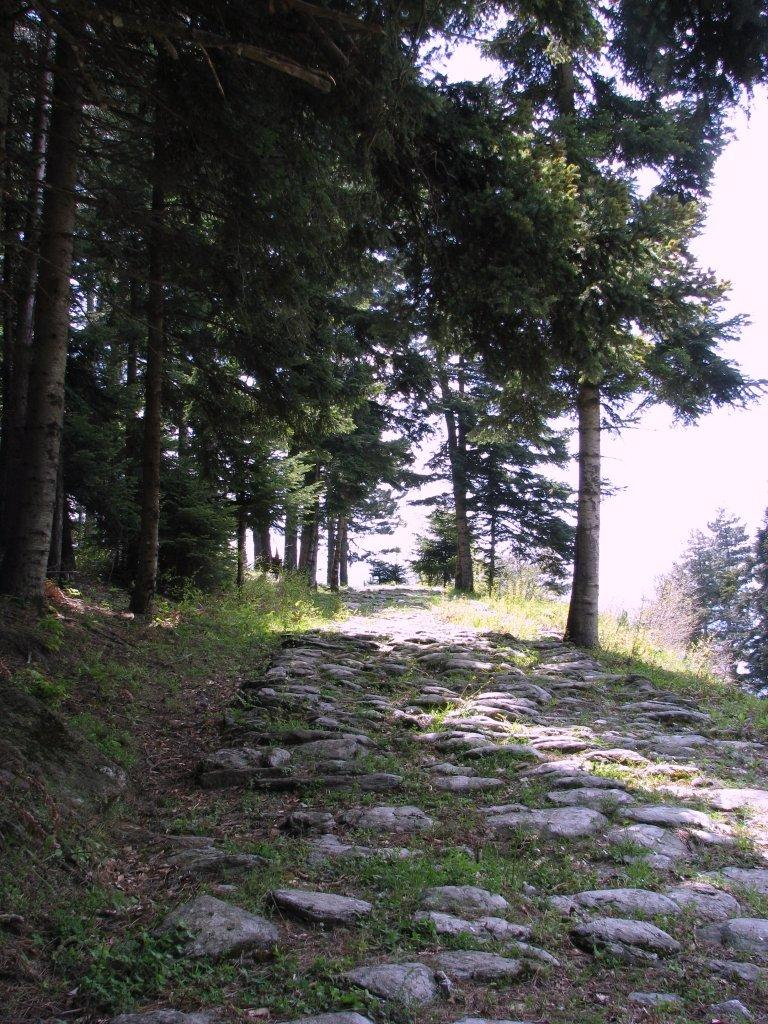What type of vegetation can be seen in the image? There are trees in the image. What is visible in the background of the image? The sky is visible behind the trees. What type of terrain is present at the bottom of the image? There are rocks on the land at the bottom of the image. What type of fish can be seen swimming in the image? There are no fish present in the image; it features trees, sky, and rocks. 